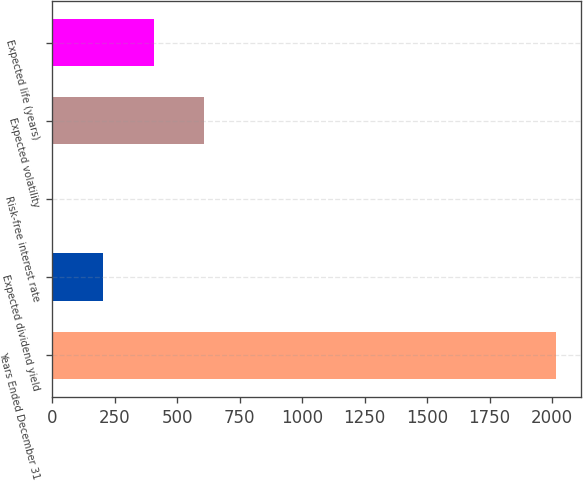Convert chart. <chart><loc_0><loc_0><loc_500><loc_500><bar_chart><fcel>Years Ended December 31<fcel>Expected dividend yield<fcel>Risk-free interest rate<fcel>Expected volatility<fcel>Expected life (years)<nl><fcel>2017<fcel>203.5<fcel>2<fcel>606.5<fcel>405<nl></chart> 